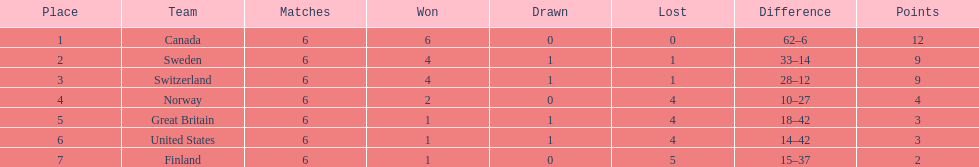What was the number of points won by great britain? 3. 